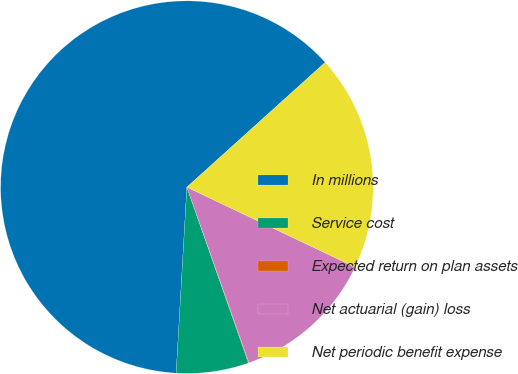Convert chart to OTSL. <chart><loc_0><loc_0><loc_500><loc_500><pie_chart><fcel>In millions<fcel>Service cost<fcel>Expected return on plan assets<fcel>Net actuarial (gain) loss<fcel>Net periodic benefit expense<nl><fcel>62.4%<fcel>6.28%<fcel>0.05%<fcel>12.52%<fcel>18.75%<nl></chart> 